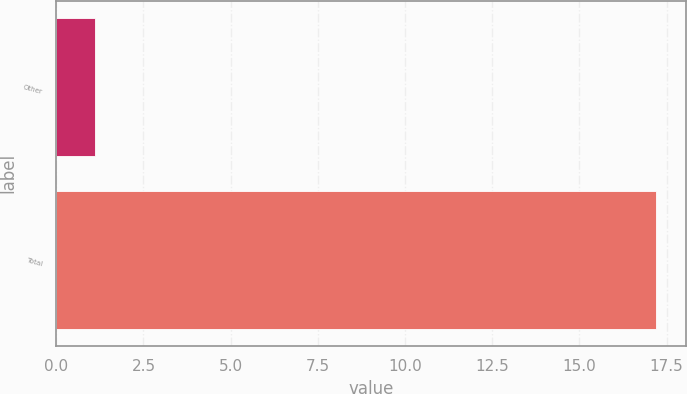Convert chart. <chart><loc_0><loc_0><loc_500><loc_500><bar_chart><fcel>Other<fcel>Total<nl><fcel>1.1<fcel>17.2<nl></chart> 